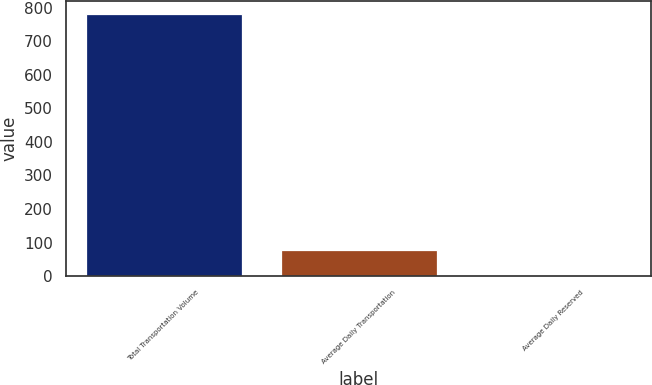Convert chart. <chart><loc_0><loc_0><loc_500><loc_500><bar_chart><fcel>Total Transportation Volume<fcel>Average Daily Transportation<fcel>Average Daily Reserved<nl><fcel>781<fcel>78.73<fcel>0.7<nl></chart> 